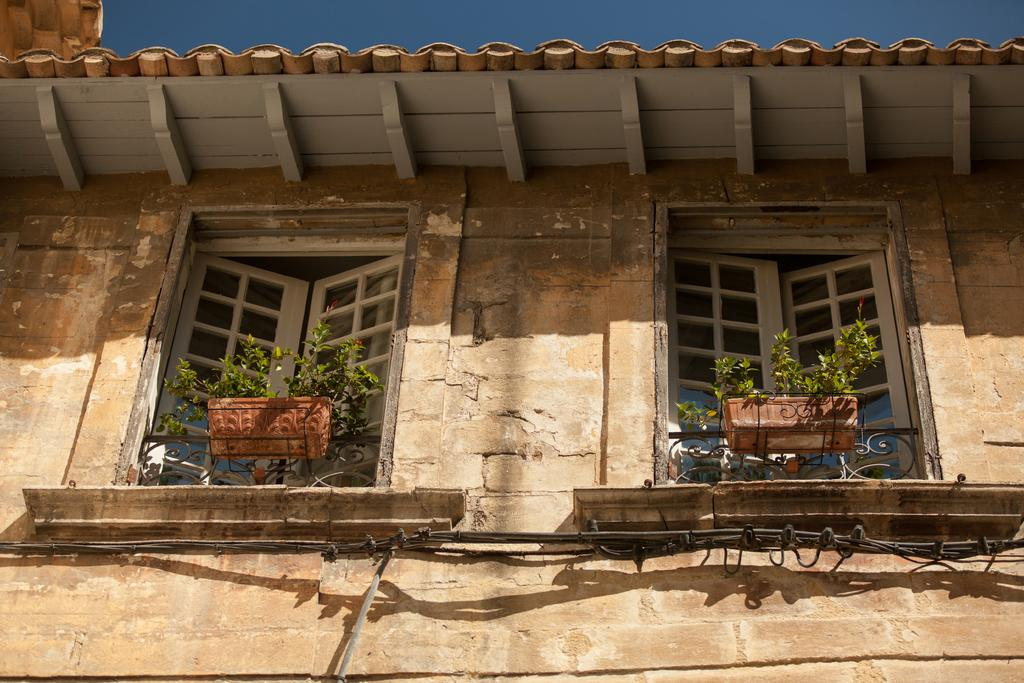What can be seen in the center of the image? The sky is visible in the center of the image. What architectural features are present in the image? There are windows, a building, a wall, and a roof visible in the image. Are there any objects related to plants in the image? Yes, plant pots are present in the image. How many times does the bat fly across the image? There is no bat present in the image, so it cannot be determined how many times it flies across the image. 